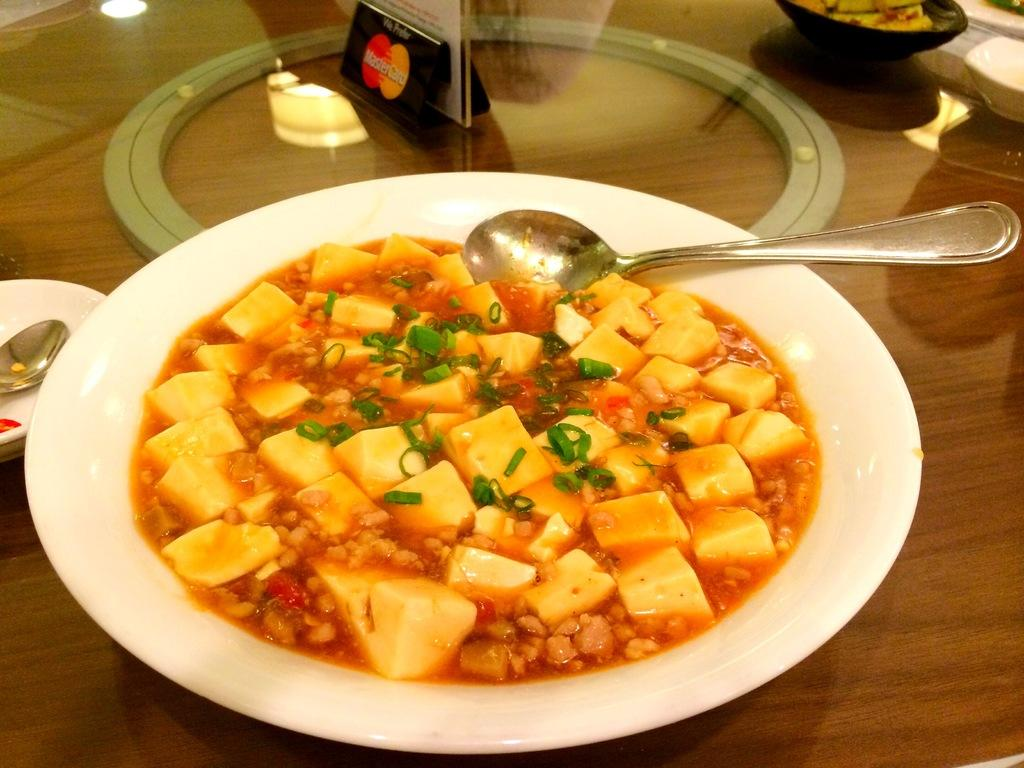What is on the plate that is visible in the image? There is a food item on the plate in the image. What utensil can be seen in the image? There is a spoon in the image. What type of dishware is present in the image? There are bowls and plates in the image. Where is the object located in the image? The object is on a glass table in the image. What type of book is visible on the glass table in the image? There is no book present on the glass table in the image. What is the condition of the zebra in the image? There is no zebra present in the image. 